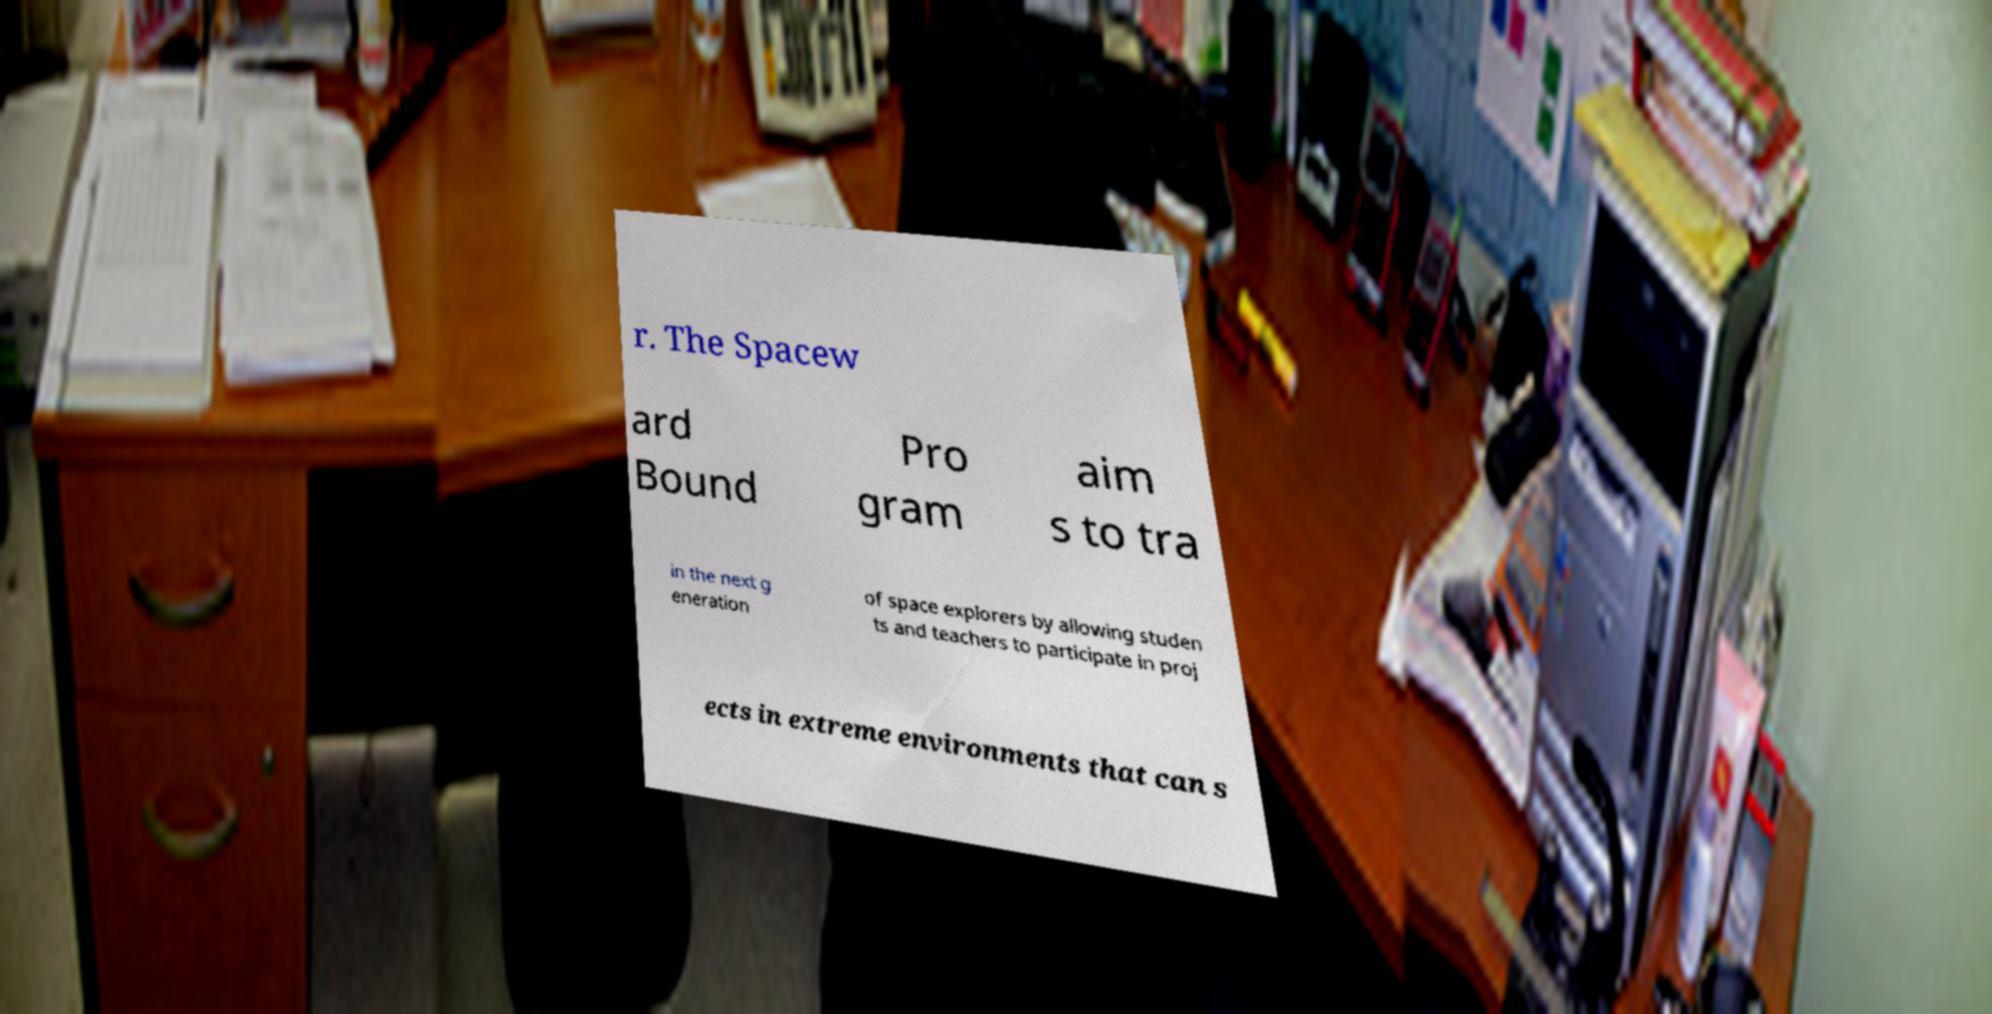Could you assist in decoding the text presented in this image and type it out clearly? r. The Spacew ard Bound Pro gram aim s to tra in the next g eneration of space explorers by allowing studen ts and teachers to participate in proj ects in extreme environments that can s 